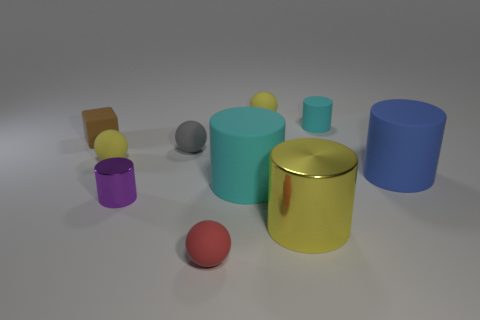Subtract all gray rubber balls. How many balls are left? 3 Subtract all gray spheres. How many spheres are left? 3 Subtract all spheres. How many objects are left? 6 Add 2 tiny cylinders. How many tiny cylinders exist? 4 Subtract 0 blue cubes. How many objects are left? 10 Subtract 3 spheres. How many spheres are left? 1 Subtract all yellow blocks. Subtract all brown balls. How many blocks are left? 1 Subtract all purple balls. How many cyan cylinders are left? 2 Subtract all small purple matte cylinders. Subtract all big cyan things. How many objects are left? 9 Add 5 large yellow metal cylinders. How many large yellow metal cylinders are left? 6 